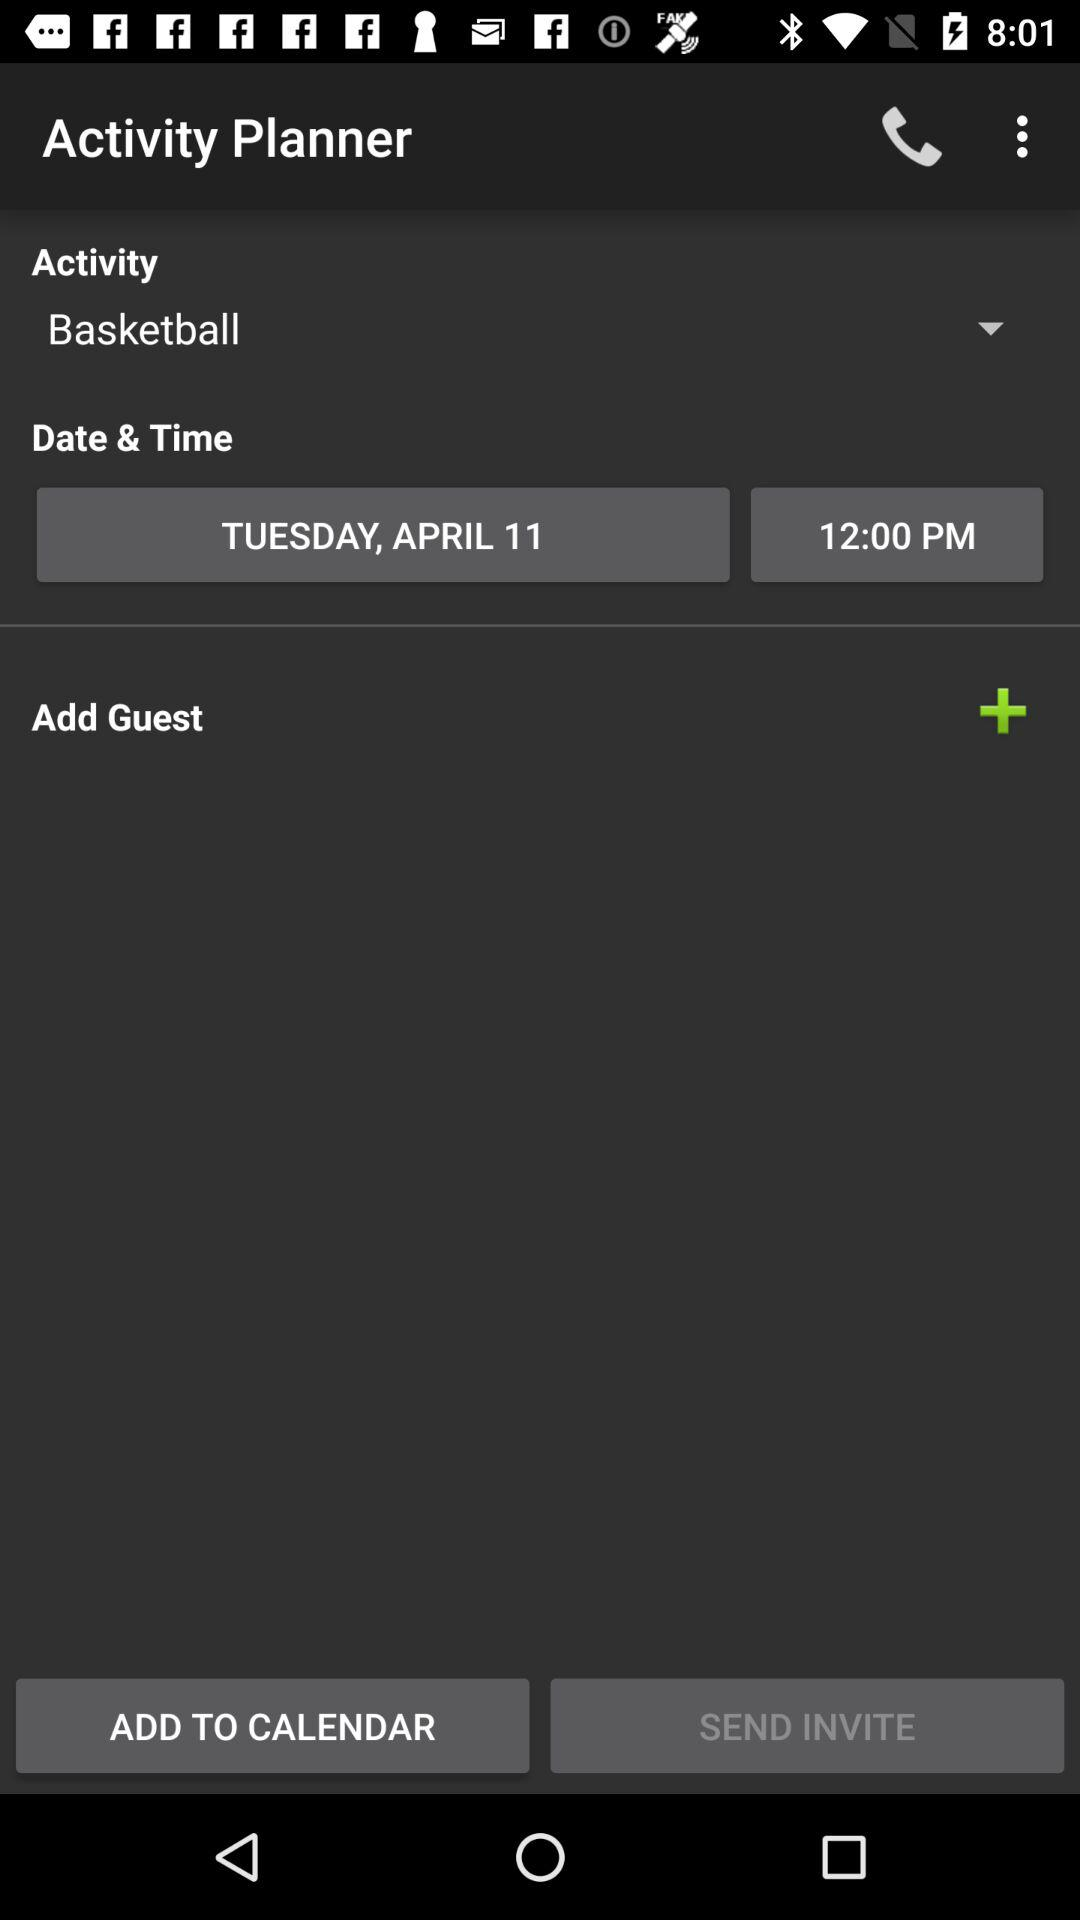What is the date and time? The date is Tuesday, April 11 and time is 12:00 PM. 